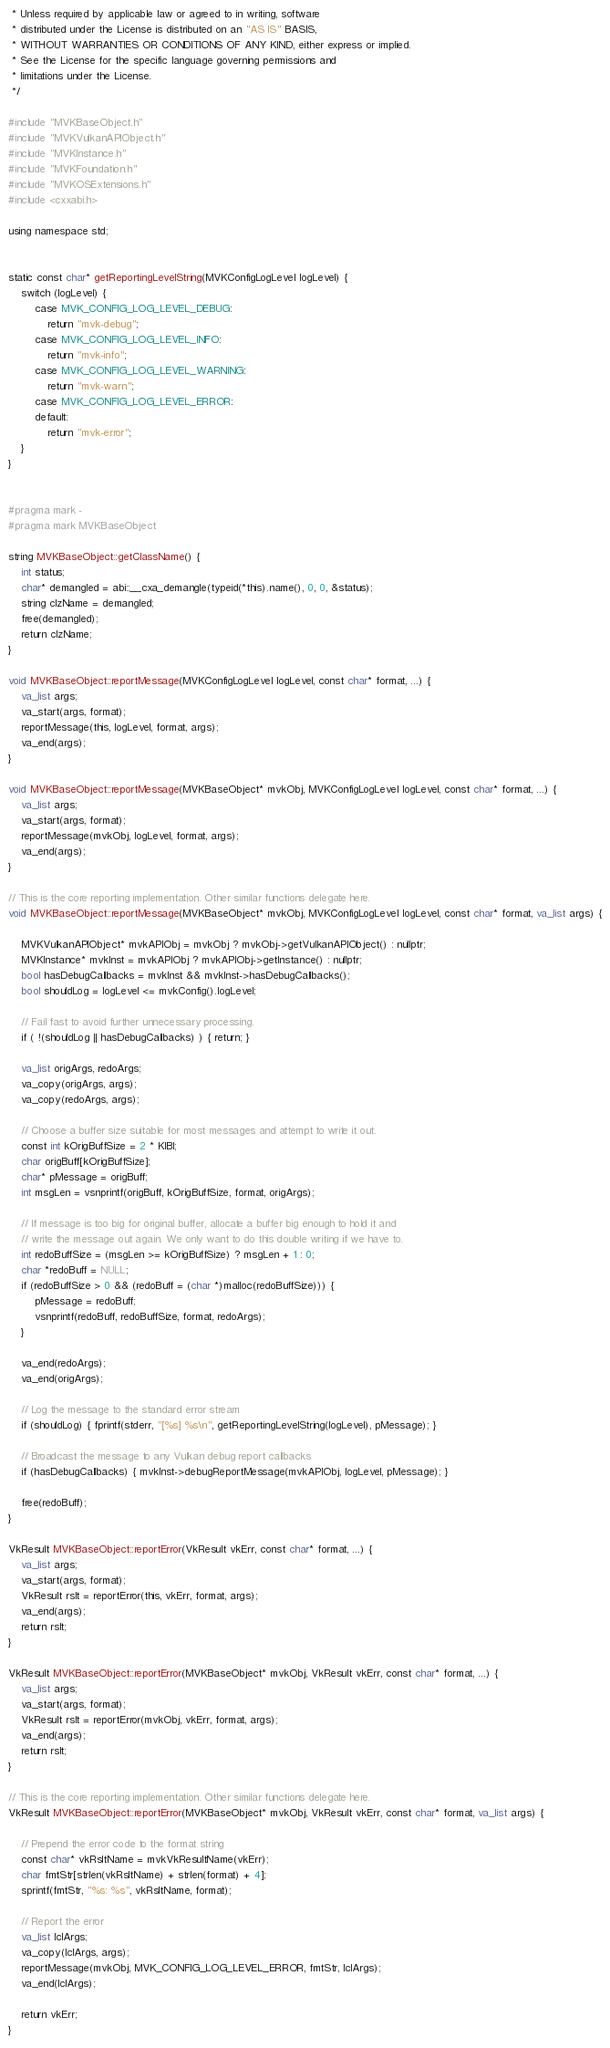<code> <loc_0><loc_0><loc_500><loc_500><_ObjectiveC_> * Unless required by applicable law or agreed to in writing, software
 * distributed under the License is distributed on an "AS IS" BASIS,
 * WITHOUT WARRANTIES OR CONDITIONS OF ANY KIND, either express or implied.
 * See the License for the specific language governing permissions and
 * limitations under the License.
 */

#include "MVKBaseObject.h"
#include "MVKVulkanAPIObject.h"
#include "MVKInstance.h"
#include "MVKFoundation.h"
#include "MVKOSExtensions.h"
#include <cxxabi.h>

using namespace std;


static const char* getReportingLevelString(MVKConfigLogLevel logLevel) {
	switch (logLevel) {
		case MVK_CONFIG_LOG_LEVEL_DEBUG:
			return "mvk-debug";
		case MVK_CONFIG_LOG_LEVEL_INFO:
			return "mvk-info";
		case MVK_CONFIG_LOG_LEVEL_WARNING:
			return "mvk-warn";
		case MVK_CONFIG_LOG_LEVEL_ERROR:
		default:
			return "mvk-error";
	}
}


#pragma mark -
#pragma mark MVKBaseObject

string MVKBaseObject::getClassName() {
    int status;
    char* demangled = abi::__cxa_demangle(typeid(*this).name(), 0, 0, &status);
    string clzName = demangled;
    free(demangled);
    return clzName;
}

void MVKBaseObject::reportMessage(MVKConfigLogLevel logLevel, const char* format, ...) {
	va_list args;
	va_start(args, format);
	reportMessage(this, logLevel, format, args);
	va_end(args);
}

void MVKBaseObject::reportMessage(MVKBaseObject* mvkObj, MVKConfigLogLevel logLevel, const char* format, ...) {
	va_list args;
	va_start(args, format);
	reportMessage(mvkObj, logLevel, format, args);
	va_end(args);
}

// This is the core reporting implementation. Other similar functions delegate here.
void MVKBaseObject::reportMessage(MVKBaseObject* mvkObj, MVKConfigLogLevel logLevel, const char* format, va_list args) {

	MVKVulkanAPIObject* mvkAPIObj = mvkObj ? mvkObj->getVulkanAPIObject() : nullptr;
	MVKInstance* mvkInst = mvkAPIObj ? mvkAPIObj->getInstance() : nullptr;
	bool hasDebugCallbacks = mvkInst && mvkInst->hasDebugCallbacks();
	bool shouldLog = logLevel <= mvkConfig().logLevel;

	// Fail fast to avoid further unnecessary processing.
	if ( !(shouldLog || hasDebugCallbacks) ) { return; }

	va_list origArgs, redoArgs;
	va_copy(origArgs, args);
	va_copy(redoArgs, args);

	// Choose a buffer size suitable for most messages and attempt to write it out.
	const int kOrigBuffSize = 2 * KIBI;
	char origBuff[kOrigBuffSize];
	char* pMessage = origBuff;
	int msgLen = vsnprintf(origBuff, kOrigBuffSize, format, origArgs);

	// If message is too big for original buffer, allocate a buffer big enough to hold it and
	// write the message out again. We only want to do this double writing if we have to.
	int redoBuffSize = (msgLen >= kOrigBuffSize) ? msgLen + 1 : 0;
	char *redoBuff = NULL;
	if (redoBuffSize > 0 && (redoBuff = (char *)malloc(redoBuffSize))) {
		pMessage = redoBuff;
		vsnprintf(redoBuff, redoBuffSize, format, redoArgs);
	}

	va_end(redoArgs);
	va_end(origArgs);

	// Log the message to the standard error stream
	if (shouldLog) { fprintf(stderr, "[%s] %s\n", getReportingLevelString(logLevel), pMessage); }

	// Broadcast the message to any Vulkan debug report callbacks
	if (hasDebugCallbacks) { mvkInst->debugReportMessage(mvkAPIObj, logLevel, pMessage); }

	free(redoBuff);
}

VkResult MVKBaseObject::reportError(VkResult vkErr, const char* format, ...) {
	va_list args;
	va_start(args, format);
	VkResult rslt = reportError(this, vkErr, format, args);
	va_end(args);
	return rslt;
}

VkResult MVKBaseObject::reportError(MVKBaseObject* mvkObj, VkResult vkErr, const char* format, ...) {
	va_list args;
	va_start(args, format);
	VkResult rslt = reportError(mvkObj, vkErr, format, args);
	va_end(args);
	return rslt;
}

// This is the core reporting implementation. Other similar functions delegate here.
VkResult MVKBaseObject::reportError(MVKBaseObject* mvkObj, VkResult vkErr, const char* format, va_list args) {

	// Prepend the error code to the format string
	const char* vkRsltName = mvkVkResultName(vkErr);
	char fmtStr[strlen(vkRsltName) + strlen(format) + 4];
	sprintf(fmtStr, "%s: %s", vkRsltName, format);
    
	// Report the error
	va_list lclArgs;
	va_copy(lclArgs, args);
	reportMessage(mvkObj, MVK_CONFIG_LOG_LEVEL_ERROR, fmtStr, lclArgs);
	va_end(lclArgs);

	return vkErr;
}
</code> 